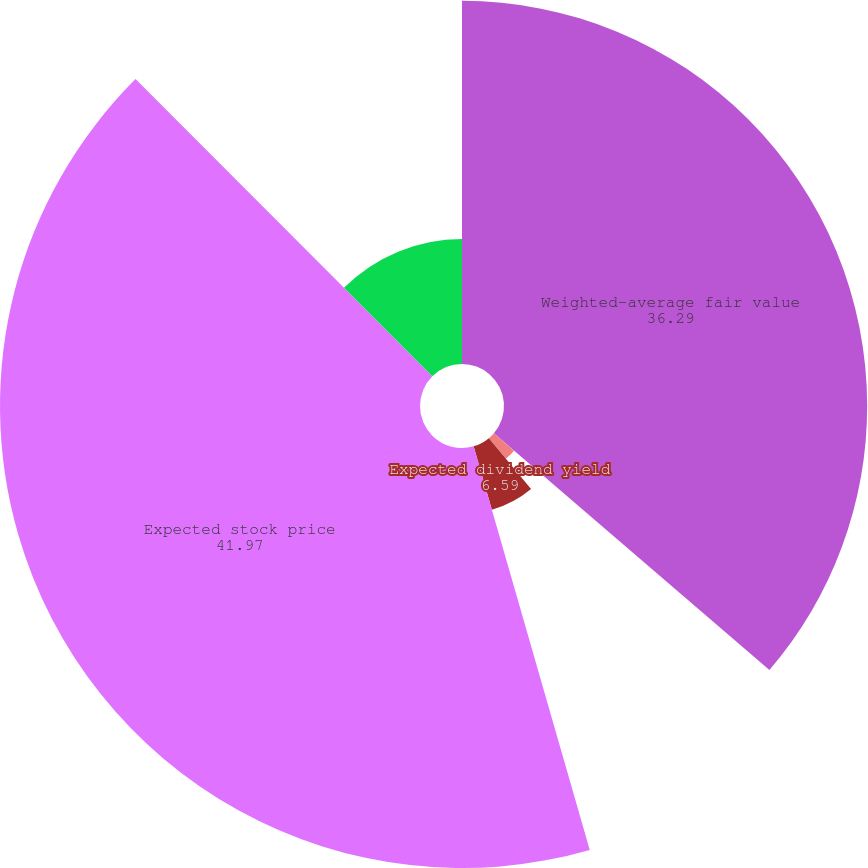Convert chart to OTSL. <chart><loc_0><loc_0><loc_500><loc_500><pie_chart><fcel>Weighted-average fair value<fcel>Risk-free interest rate<fcel>Expected dividend yield<fcel>Expected stock price<fcel>Expected option life (years)<nl><fcel>36.29%<fcel>2.66%<fcel>6.59%<fcel>41.97%<fcel>12.49%<nl></chart> 